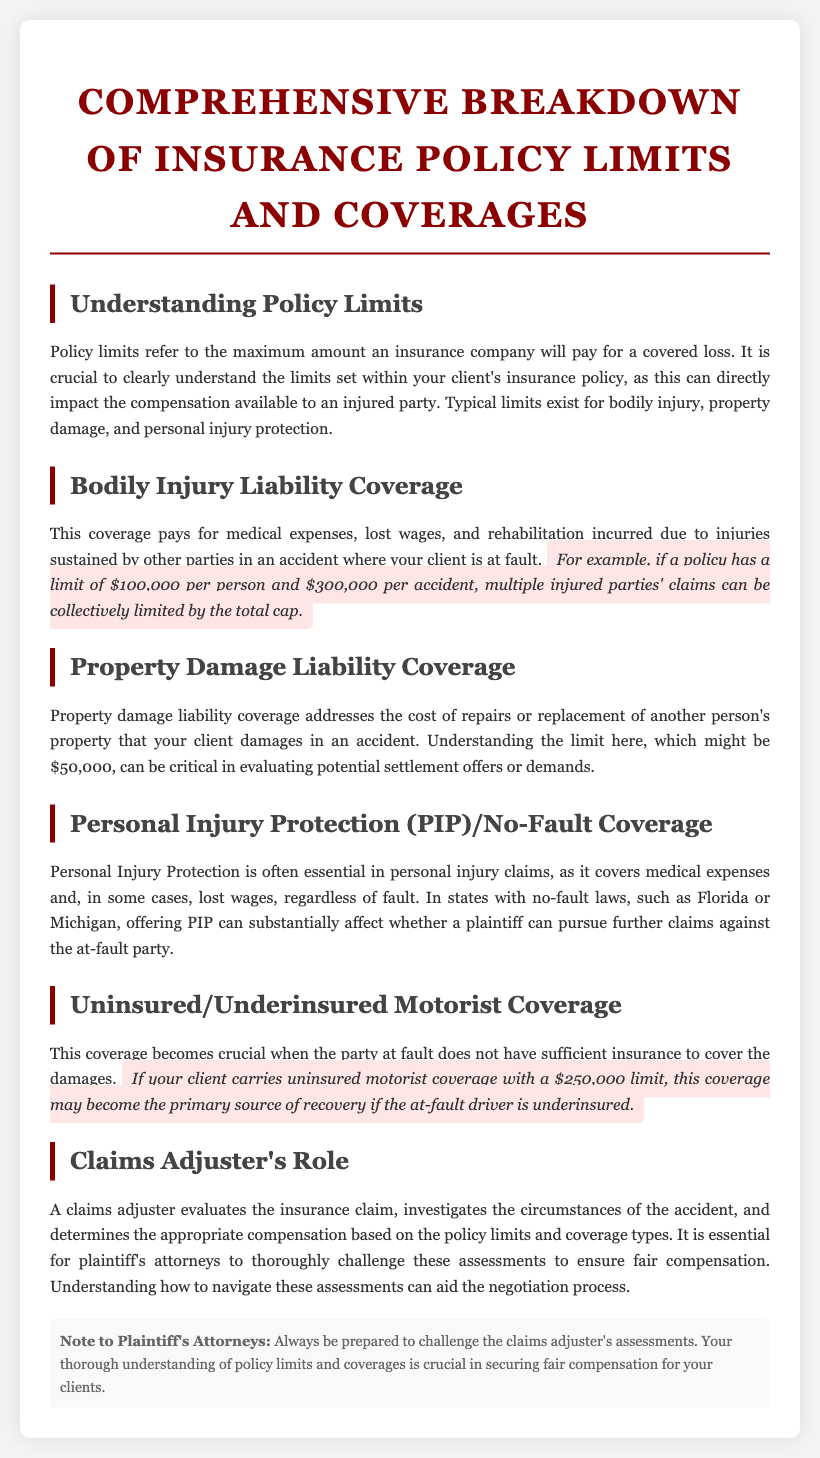What do policy limits refer to? Policy limits refer to the maximum amount an insurance company will pay for a covered loss.
Answer: Maximum amount What is the limit for bodily injury liability coverage per person? The document states that a typical limit for bodily injury liability coverage is $100,000 per person.
Answer: $100,000 What is the typical limit for property damage liability coverage? The document indicates that a typical limit for property damage liability coverage might be $50,000.
Answer: $50,000 What is the role of a claims adjuster? A claims adjuster evaluates the insurance claim, investigates the circumstances of the accident, and determines appropriate compensation.
Answer: Evaluates claims What type of coverage is essential in personal injury claims? The document mentions that Personal Injury Protection (PIP) is often essential in personal injury claims.
Answer: Personal Injury Protection How might uninsured motorist coverage assist your client? Uninsured motorist coverage may become the primary source of recovery if the at-fault driver is underinsured.
Answer: Primary source of recovery In which states is PIP commonly offered? The document states that PIP is often offered in states with no-fault laws, such as Florida or Michigan.
Answer: Florida, Michigan What is critical to understand when evaluating settlement offers? Understanding the limits of property damage liability coverage can be critical in evaluating potential settlement offers or demands.
Answer: Property damage limits What should plaintiff's attorneys be prepared to do? Plaintiff's attorneys should always be prepared to challenge the claims adjuster's assessments.
Answer: Challenge assessments 